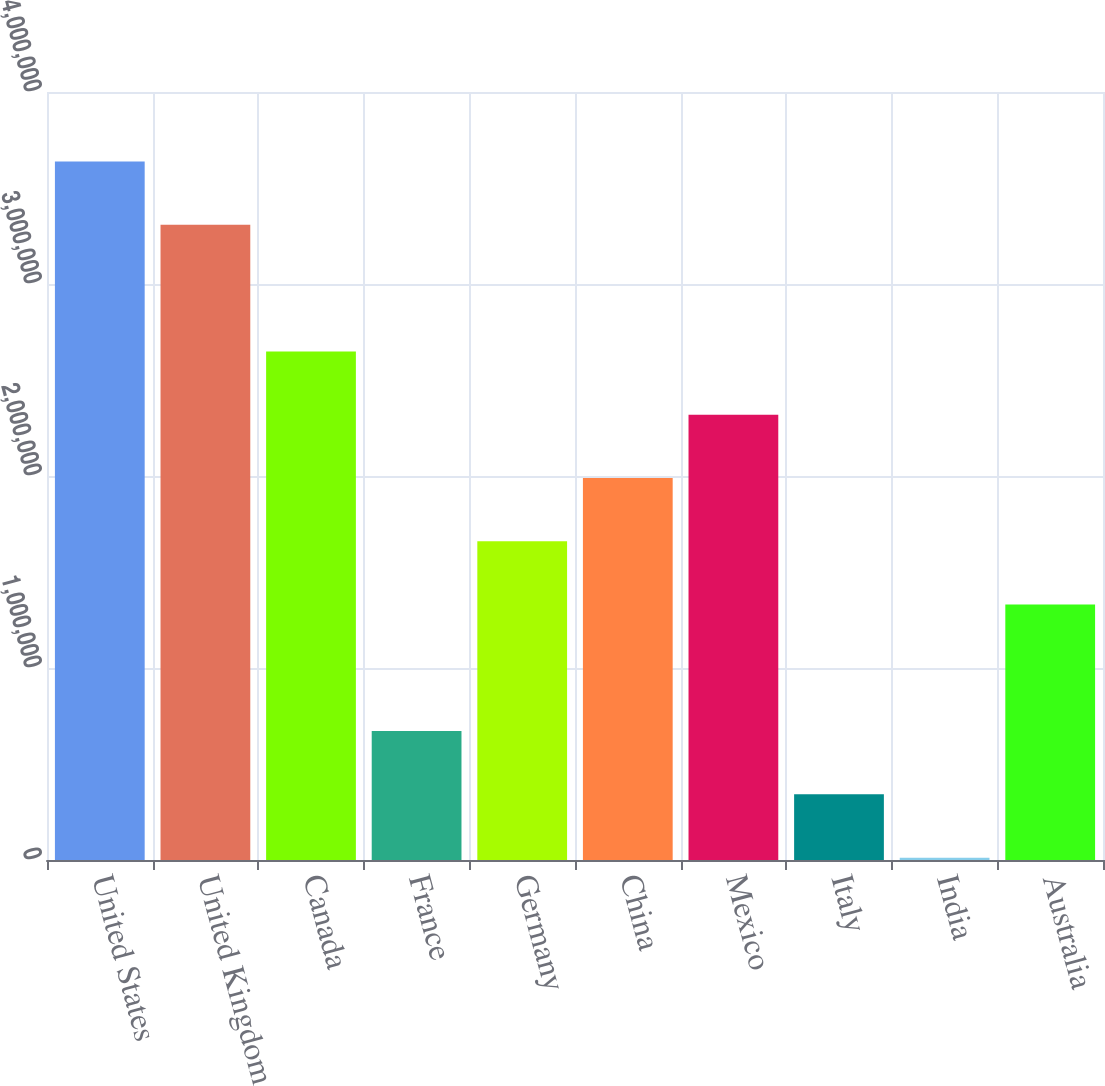Convert chart. <chart><loc_0><loc_0><loc_500><loc_500><bar_chart><fcel>United States<fcel>United Kingdom<fcel>Canada<fcel>France<fcel>Germany<fcel>China<fcel>Mexico<fcel>Italy<fcel>India<fcel>Australia<nl><fcel>3.63756e+06<fcel>3.308e+06<fcel>2.64887e+06<fcel>671476<fcel>1.66017e+06<fcel>1.98974e+06<fcel>2.3193e+06<fcel>341910<fcel>12345<fcel>1.33061e+06<nl></chart> 